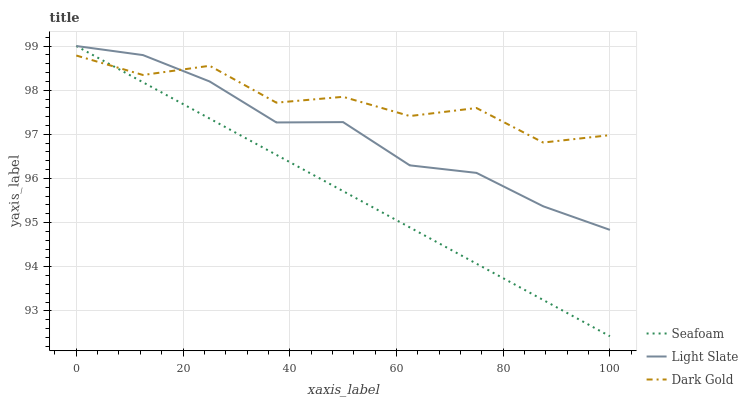Does Seafoam have the minimum area under the curve?
Answer yes or no. Yes. Does Dark Gold have the maximum area under the curve?
Answer yes or no. Yes. Does Dark Gold have the minimum area under the curve?
Answer yes or no. No. Does Seafoam have the maximum area under the curve?
Answer yes or no. No. Is Seafoam the smoothest?
Answer yes or no. Yes. Is Dark Gold the roughest?
Answer yes or no. Yes. Is Dark Gold the smoothest?
Answer yes or no. No. Is Seafoam the roughest?
Answer yes or no. No. Does Seafoam have the lowest value?
Answer yes or no. Yes. Does Dark Gold have the lowest value?
Answer yes or no. No. Does Seafoam have the highest value?
Answer yes or no. Yes. Does Dark Gold have the highest value?
Answer yes or no. No. Does Dark Gold intersect Seafoam?
Answer yes or no. Yes. Is Dark Gold less than Seafoam?
Answer yes or no. No. Is Dark Gold greater than Seafoam?
Answer yes or no. No. 